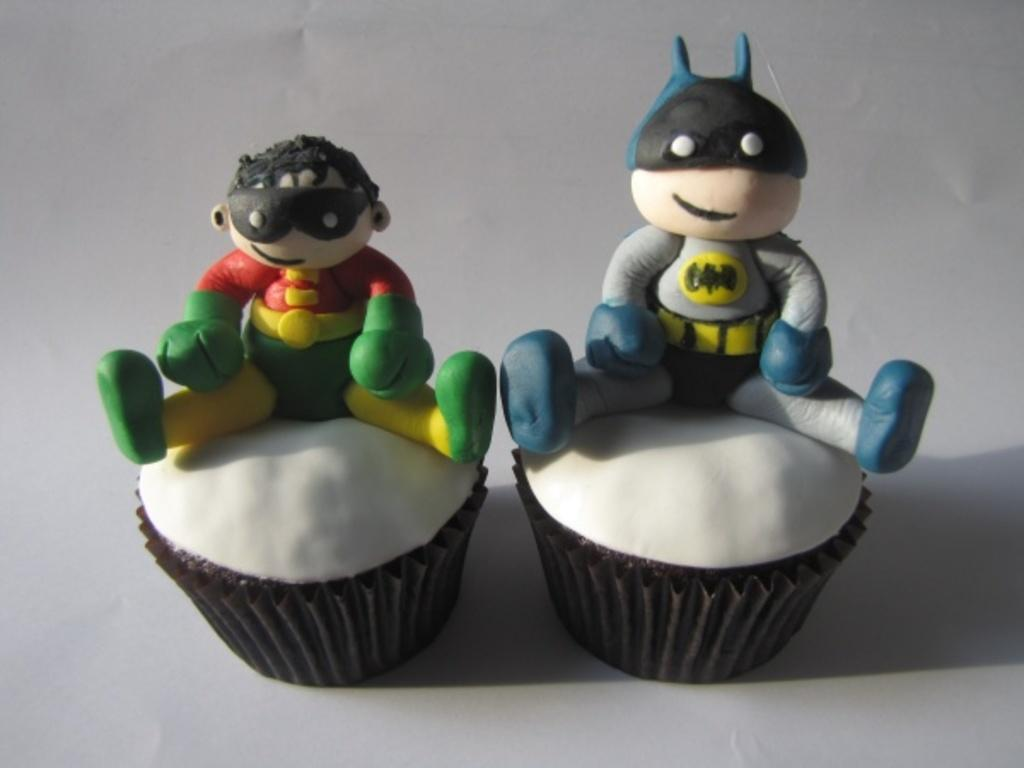How many cupcakes are visible in the image? There are two cupcakes in the image. What is on top of the cupcakes? There are cartoon dolls on top of the cupcakes. What type of pan is used to bake the cupcakes in the image? There is no pan visible in the image, and the baking process is not shown. 